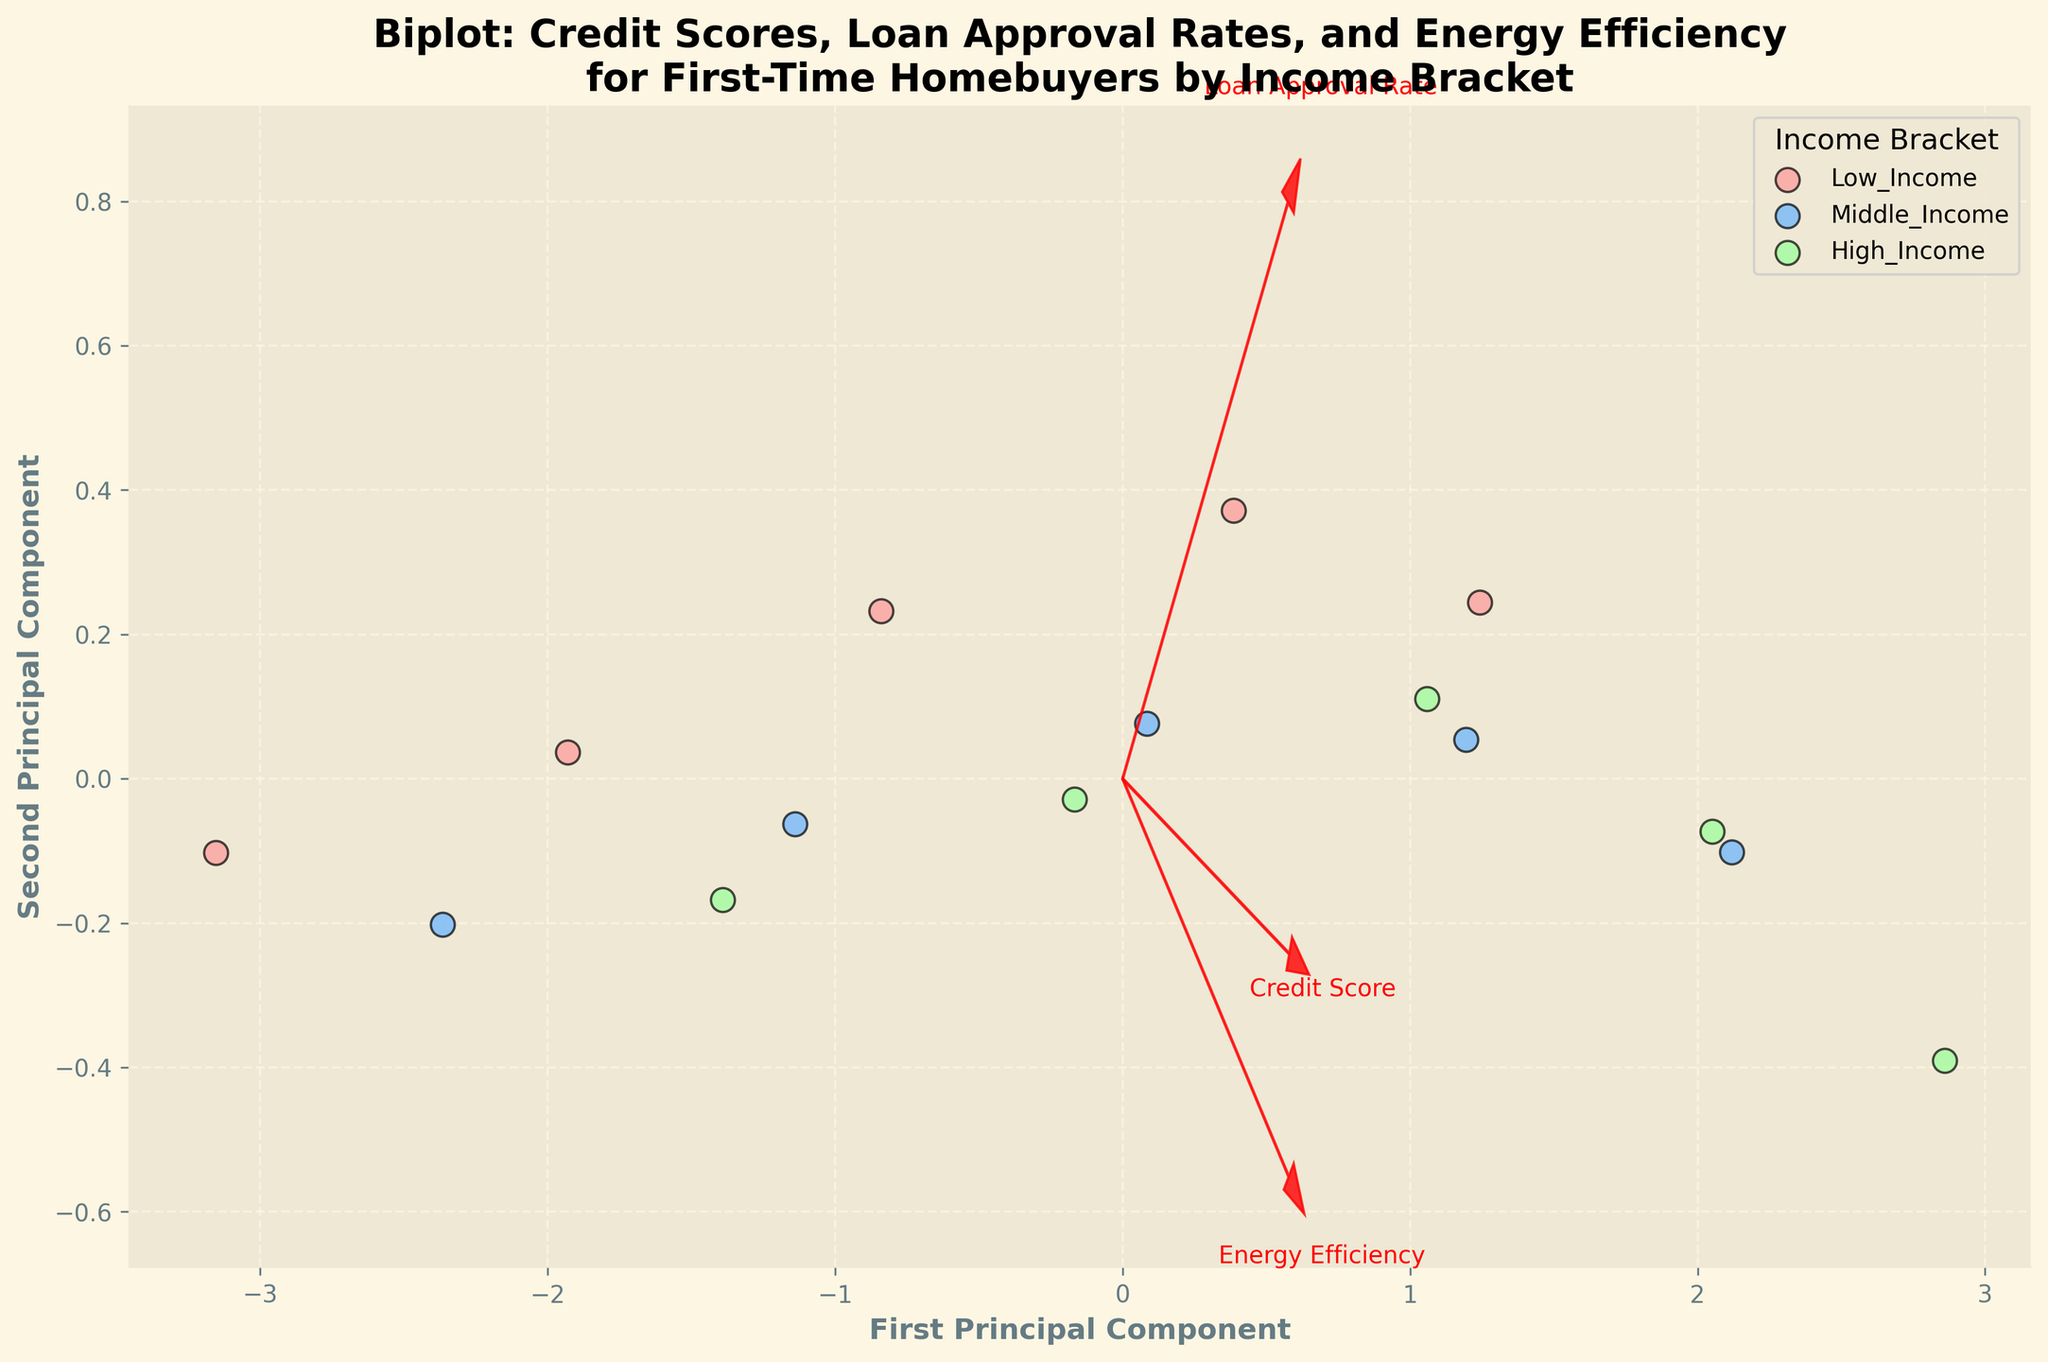What is the title of the figure? The title is displayed at the top of the figure, which reads "Biplot: Credit Scores, Loan Approval Rates, and Energy Efficiency for First-Time Homebuyers by Income Bracket".
Answer: Biplot: Credit Scores, Loan Approval Rates, and Energy Efficiency for First-Time Homebuyers by Income Bracket How many principal components are used in the plot? The x-axis and y-axis are labeled as "First Principal Component" and "Second Principal Component", indicating that the plot uses two principal components.
Answer: Two Which income bracket is represented by the green color? By looking at the legend in the figure, the green color represents the "High_Income" bracket.
Answer: High_Income What direction does the "Credit Score" vector point to? Observe where the "Credit Score" vector (labeled in red) is pointing from the origin. It points approximately to the right.
Answer: Right Which income bracket appears to have the highest concentration of loan approval rates? By observing the dispersal of data points along the PC space, the "High_Income" bracket (green) appears to have data points closer to the higher loan approval rates axis, indicated by the arrow direction of "Loan Approval Rate".
Answer: High_Income Which feature vector is longest and what might this indicate? By comparing the lengths of the feature vectors, "Credit Score" has the longest vector. This suggests that "Credit Score" contributes most significantly to the variation in the data captured by the first two principal components.
Answer: Credit Score Are loan approval rates generally higher for higher credit scores? By observing the general trend of data points and the direction of the feature vectors, data points with higher credit scores correspond to higher loan approval rates, confirming a positive correlation.
Answer: Yes Which feature seems to have the least impact on the first two principal components? By examining the relative lengths of the feature vectors, "Energy Efficiency" has the shortest vector, indicating it has the least impact on the first two principal components.
Answer: Energy Efficiency Compare the clustering of data points for low-income and high-income brackets. Low-income (red) points are more spread out indicating higher variability, while high-income (green) points are more clustered, indicating less variability in credit scores and loan approval rates among high-income individuals.
Answer: Low-income points are more spread out; high-income points are more clustered In which principal component direction is "Loan Approval Rate" most aligned? The "Loan Approval Rate" vector is most aligned with the first principal component, indicated by its direction and the larger portion of its vector along the PC1 axis compared to the PC2 axis.
Answer: First Principal Component 